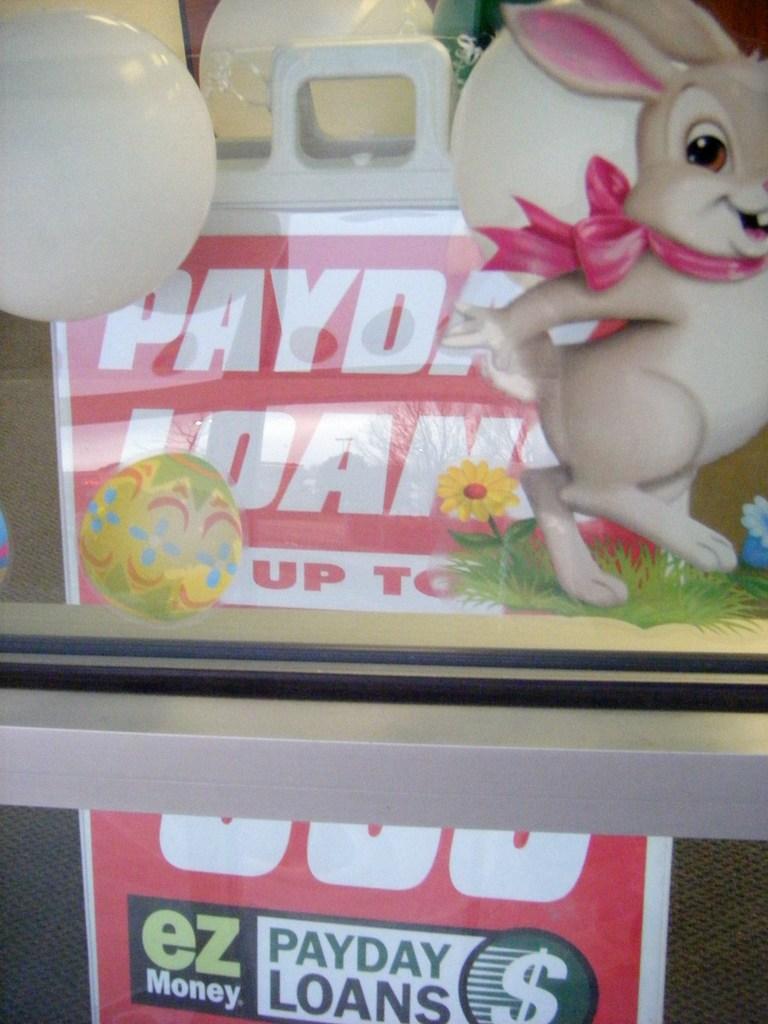What type of loan?
Give a very brief answer. Payday. 